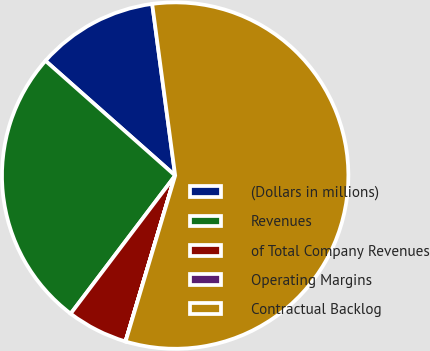Convert chart to OTSL. <chart><loc_0><loc_0><loc_500><loc_500><pie_chart><fcel>(Dollars in millions)<fcel>Revenues<fcel>of Total Company Revenues<fcel>Operating Margins<fcel>Contractual Backlog<nl><fcel>11.35%<fcel>26.22%<fcel>5.68%<fcel>0.01%<fcel>56.74%<nl></chart> 